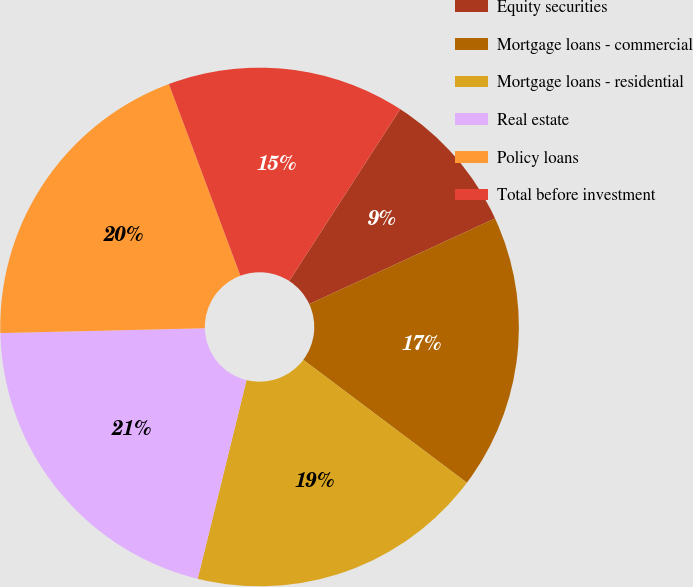<chart> <loc_0><loc_0><loc_500><loc_500><pie_chart><fcel>Equity securities<fcel>Mortgage loans - commercial<fcel>Mortgage loans - residential<fcel>Real estate<fcel>Policy loans<fcel>Total before investment<nl><fcel>9.0%<fcel>17.13%<fcel>18.58%<fcel>20.79%<fcel>19.69%<fcel>14.81%<nl></chart> 